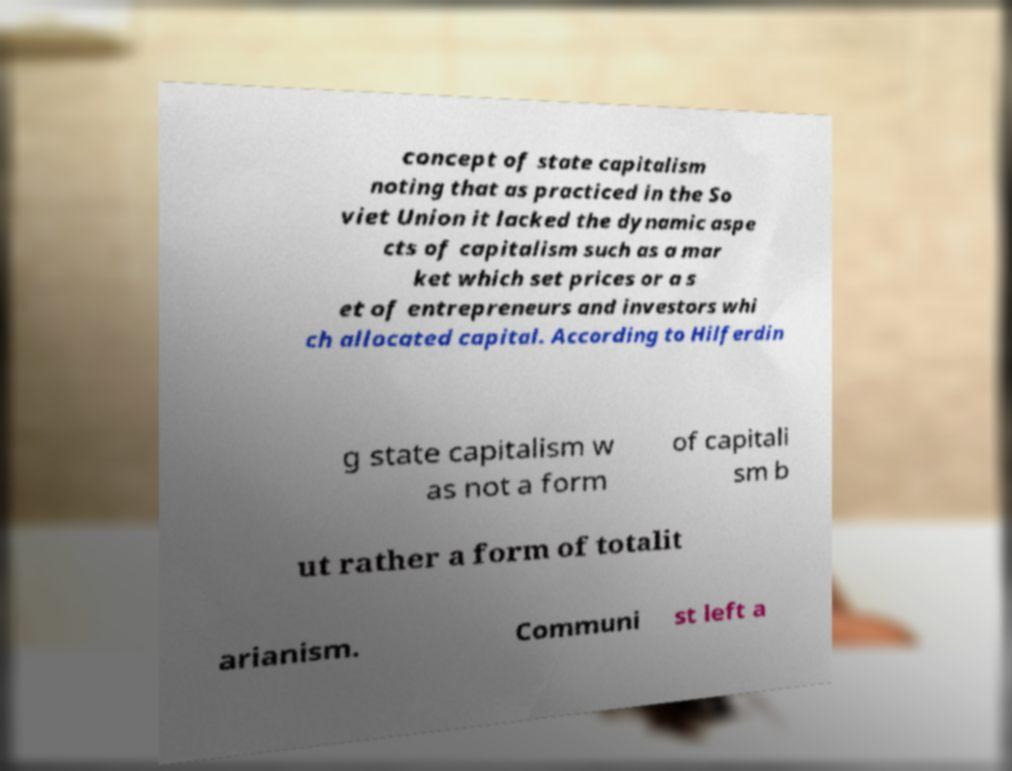For documentation purposes, I need the text within this image transcribed. Could you provide that? concept of state capitalism noting that as practiced in the So viet Union it lacked the dynamic aspe cts of capitalism such as a mar ket which set prices or a s et of entrepreneurs and investors whi ch allocated capital. According to Hilferdin g state capitalism w as not a form of capitali sm b ut rather a form of totalit arianism. Communi st left a 